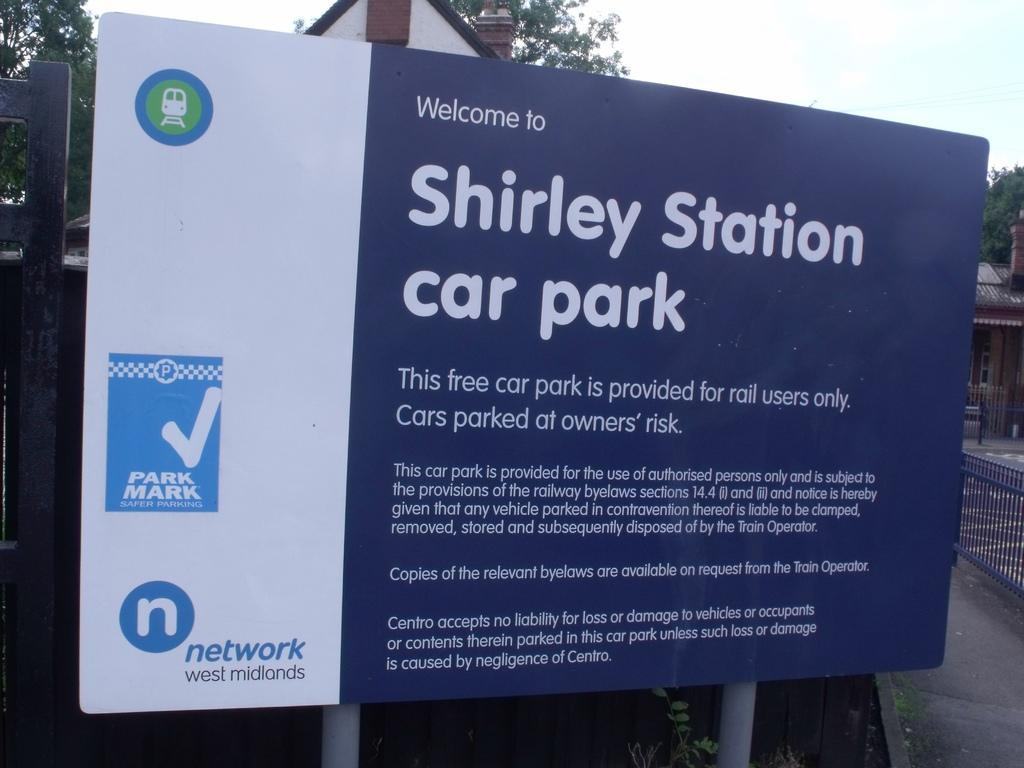<image>
Write a terse but informative summary of the picture. Welcome to Shirley Station Car park banner with a network logo 